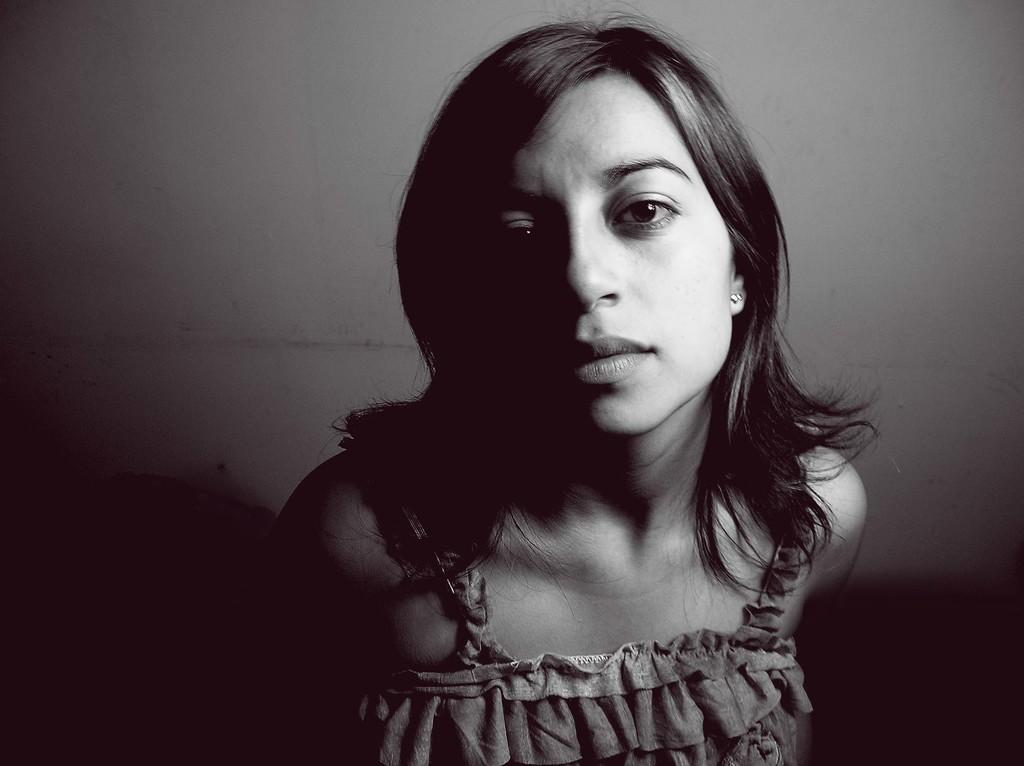Who is present in the image? There is a woman in the image. What type of bead is the woman using to hammer her authority in the image? There is no bead or hammer present in the image, and the woman is not depicted as exercising authority. 